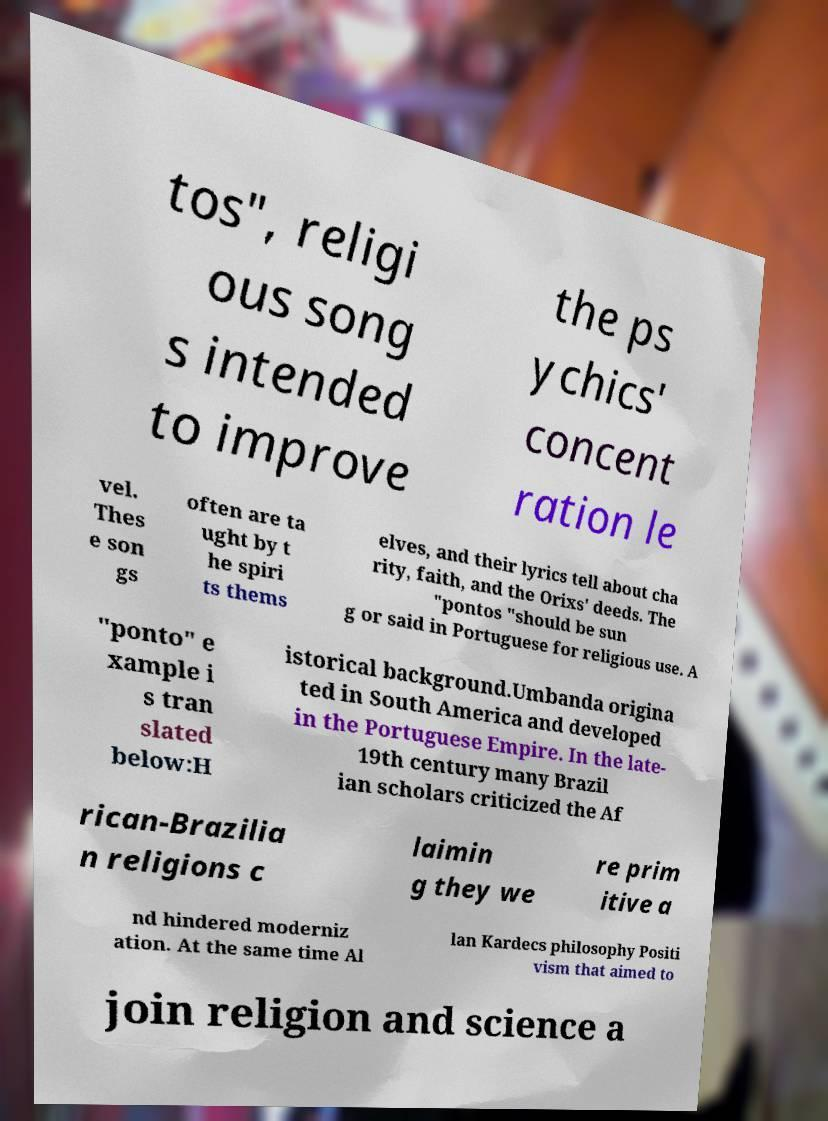Can you accurately transcribe the text from the provided image for me? tos", religi ous song s intended to improve the ps ychics' concent ration le vel. Thes e son gs often are ta ught by t he spiri ts thems elves, and their lyrics tell about cha rity, faith, and the Orixs' deeds. The "pontos "should be sun g or said in Portuguese for religious use. A "ponto" e xample i s tran slated below:H istorical background.Umbanda origina ted in South America and developed in the Portuguese Empire. In the late- 19th century many Brazil ian scholars criticized the Af rican-Brazilia n religions c laimin g they we re prim itive a nd hindered moderniz ation. At the same time Al lan Kardecs philosophy Positi vism that aimed to join religion and science a 